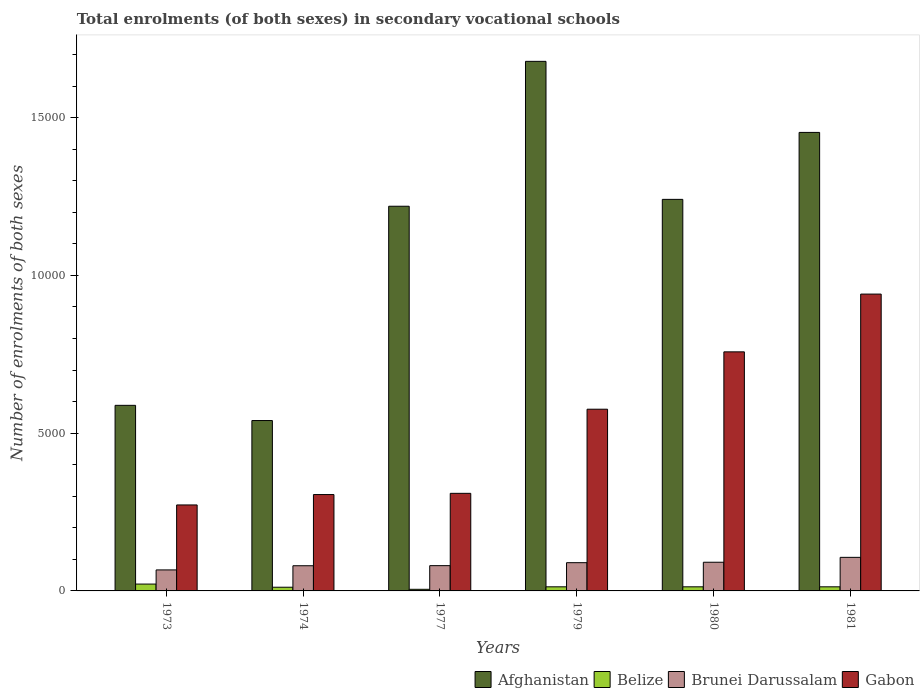How many different coloured bars are there?
Ensure brevity in your answer.  4. Are the number of bars on each tick of the X-axis equal?
Give a very brief answer. Yes. How many bars are there on the 3rd tick from the left?
Provide a short and direct response. 4. What is the number of enrolments in secondary schools in Brunei Darussalam in 1977?
Ensure brevity in your answer.  801. Across all years, what is the maximum number of enrolments in secondary schools in Brunei Darussalam?
Keep it short and to the point. 1064. Across all years, what is the minimum number of enrolments in secondary schools in Gabon?
Provide a succinct answer. 2725. In which year was the number of enrolments in secondary schools in Brunei Darussalam maximum?
Your answer should be very brief. 1981. In which year was the number of enrolments in secondary schools in Afghanistan minimum?
Keep it short and to the point. 1974. What is the total number of enrolments in secondary schools in Brunei Darussalam in the graph?
Keep it short and to the point. 5133. What is the difference between the number of enrolments in secondary schools in Afghanistan in 1979 and that in 1981?
Your answer should be very brief. 2252. What is the difference between the number of enrolments in secondary schools in Belize in 1981 and the number of enrolments in secondary schools in Brunei Darussalam in 1977?
Give a very brief answer. -671. What is the average number of enrolments in secondary schools in Belize per year?
Ensure brevity in your answer.  129.17. In the year 1974, what is the difference between the number of enrolments in secondary schools in Gabon and number of enrolments in secondary schools in Afghanistan?
Keep it short and to the point. -2346. In how many years, is the number of enrolments in secondary schools in Brunei Darussalam greater than 3000?
Make the answer very short. 0. What is the ratio of the number of enrolments in secondary schools in Belize in 1979 to that in 1980?
Offer a terse response. 1. Is the number of enrolments in secondary schools in Belize in 1980 less than that in 1981?
Offer a very short reply. No. Is the difference between the number of enrolments in secondary schools in Gabon in 1974 and 1980 greater than the difference between the number of enrolments in secondary schools in Afghanistan in 1974 and 1980?
Offer a very short reply. Yes. What is the difference between the highest and the second highest number of enrolments in secondary schools in Afghanistan?
Ensure brevity in your answer.  2252. What is the difference between the highest and the lowest number of enrolments in secondary schools in Afghanistan?
Your answer should be compact. 1.14e+04. Is the sum of the number of enrolments in secondary schools in Gabon in 1973 and 1981 greater than the maximum number of enrolments in secondary schools in Belize across all years?
Make the answer very short. Yes. What does the 1st bar from the left in 1974 represents?
Make the answer very short. Afghanistan. What does the 2nd bar from the right in 1974 represents?
Your answer should be compact. Brunei Darussalam. Is it the case that in every year, the sum of the number of enrolments in secondary schools in Afghanistan and number of enrolments in secondary schools in Brunei Darussalam is greater than the number of enrolments in secondary schools in Belize?
Your response must be concise. Yes. How many bars are there?
Provide a short and direct response. 24. Are all the bars in the graph horizontal?
Your answer should be very brief. No. Does the graph contain grids?
Provide a succinct answer. No. Where does the legend appear in the graph?
Provide a succinct answer. Bottom right. How many legend labels are there?
Keep it short and to the point. 4. What is the title of the graph?
Offer a terse response. Total enrolments (of both sexes) in secondary vocational schools. What is the label or title of the Y-axis?
Give a very brief answer. Number of enrolments of both sexes. What is the Number of enrolments of both sexes of Afghanistan in 1973?
Provide a short and direct response. 5882. What is the Number of enrolments of both sexes in Belize in 1973?
Provide a succinct answer. 217. What is the Number of enrolments of both sexes of Brunei Darussalam in 1973?
Offer a very short reply. 666. What is the Number of enrolments of both sexes in Gabon in 1973?
Your answer should be compact. 2725. What is the Number of enrolments of both sexes of Afghanistan in 1974?
Provide a short and direct response. 5400. What is the Number of enrolments of both sexes in Belize in 1974?
Give a very brief answer. 117. What is the Number of enrolments of both sexes in Brunei Darussalam in 1974?
Keep it short and to the point. 798. What is the Number of enrolments of both sexes of Gabon in 1974?
Provide a succinct answer. 3054. What is the Number of enrolments of both sexes of Afghanistan in 1977?
Offer a terse response. 1.22e+04. What is the Number of enrolments of both sexes in Belize in 1977?
Offer a terse response. 51. What is the Number of enrolments of both sexes in Brunei Darussalam in 1977?
Offer a terse response. 801. What is the Number of enrolments of both sexes in Gabon in 1977?
Make the answer very short. 3093. What is the Number of enrolments of both sexes in Afghanistan in 1979?
Your response must be concise. 1.68e+04. What is the Number of enrolments of both sexes in Belize in 1979?
Your answer should be compact. 130. What is the Number of enrolments of both sexes of Brunei Darussalam in 1979?
Keep it short and to the point. 895. What is the Number of enrolments of both sexes in Gabon in 1979?
Provide a succinct answer. 5759. What is the Number of enrolments of both sexes of Afghanistan in 1980?
Your response must be concise. 1.24e+04. What is the Number of enrolments of both sexes of Belize in 1980?
Offer a terse response. 130. What is the Number of enrolments of both sexes of Brunei Darussalam in 1980?
Provide a succinct answer. 909. What is the Number of enrolments of both sexes of Gabon in 1980?
Your answer should be very brief. 7577. What is the Number of enrolments of both sexes of Afghanistan in 1981?
Ensure brevity in your answer.  1.45e+04. What is the Number of enrolments of both sexes of Belize in 1981?
Provide a succinct answer. 130. What is the Number of enrolments of both sexes in Brunei Darussalam in 1981?
Make the answer very short. 1064. What is the Number of enrolments of both sexes of Gabon in 1981?
Provide a succinct answer. 9408. Across all years, what is the maximum Number of enrolments of both sexes in Afghanistan?
Offer a terse response. 1.68e+04. Across all years, what is the maximum Number of enrolments of both sexes in Belize?
Provide a succinct answer. 217. Across all years, what is the maximum Number of enrolments of both sexes of Brunei Darussalam?
Offer a very short reply. 1064. Across all years, what is the maximum Number of enrolments of both sexes in Gabon?
Keep it short and to the point. 9408. Across all years, what is the minimum Number of enrolments of both sexes of Afghanistan?
Offer a very short reply. 5400. Across all years, what is the minimum Number of enrolments of both sexes in Belize?
Your answer should be compact. 51. Across all years, what is the minimum Number of enrolments of both sexes of Brunei Darussalam?
Provide a short and direct response. 666. Across all years, what is the minimum Number of enrolments of both sexes of Gabon?
Offer a very short reply. 2725. What is the total Number of enrolments of both sexes of Afghanistan in the graph?
Your answer should be compact. 6.72e+04. What is the total Number of enrolments of both sexes in Belize in the graph?
Your answer should be very brief. 775. What is the total Number of enrolments of both sexes of Brunei Darussalam in the graph?
Offer a very short reply. 5133. What is the total Number of enrolments of both sexes in Gabon in the graph?
Give a very brief answer. 3.16e+04. What is the difference between the Number of enrolments of both sexes of Afghanistan in 1973 and that in 1974?
Your response must be concise. 482. What is the difference between the Number of enrolments of both sexes of Brunei Darussalam in 1973 and that in 1974?
Provide a short and direct response. -132. What is the difference between the Number of enrolments of both sexes of Gabon in 1973 and that in 1974?
Ensure brevity in your answer.  -329. What is the difference between the Number of enrolments of both sexes in Afghanistan in 1973 and that in 1977?
Your response must be concise. -6310. What is the difference between the Number of enrolments of both sexes in Belize in 1973 and that in 1977?
Give a very brief answer. 166. What is the difference between the Number of enrolments of both sexes in Brunei Darussalam in 1973 and that in 1977?
Provide a short and direct response. -135. What is the difference between the Number of enrolments of both sexes in Gabon in 1973 and that in 1977?
Offer a terse response. -368. What is the difference between the Number of enrolments of both sexes in Afghanistan in 1973 and that in 1979?
Offer a terse response. -1.09e+04. What is the difference between the Number of enrolments of both sexes of Belize in 1973 and that in 1979?
Give a very brief answer. 87. What is the difference between the Number of enrolments of both sexes in Brunei Darussalam in 1973 and that in 1979?
Your answer should be very brief. -229. What is the difference between the Number of enrolments of both sexes in Gabon in 1973 and that in 1979?
Make the answer very short. -3034. What is the difference between the Number of enrolments of both sexes in Afghanistan in 1973 and that in 1980?
Your response must be concise. -6528. What is the difference between the Number of enrolments of both sexes of Belize in 1973 and that in 1980?
Offer a very short reply. 87. What is the difference between the Number of enrolments of both sexes of Brunei Darussalam in 1973 and that in 1980?
Provide a short and direct response. -243. What is the difference between the Number of enrolments of both sexes in Gabon in 1973 and that in 1980?
Your response must be concise. -4852. What is the difference between the Number of enrolments of both sexes in Afghanistan in 1973 and that in 1981?
Offer a terse response. -8650. What is the difference between the Number of enrolments of both sexes in Brunei Darussalam in 1973 and that in 1981?
Ensure brevity in your answer.  -398. What is the difference between the Number of enrolments of both sexes of Gabon in 1973 and that in 1981?
Offer a very short reply. -6683. What is the difference between the Number of enrolments of both sexes in Afghanistan in 1974 and that in 1977?
Provide a succinct answer. -6792. What is the difference between the Number of enrolments of both sexes in Gabon in 1974 and that in 1977?
Your response must be concise. -39. What is the difference between the Number of enrolments of both sexes of Afghanistan in 1974 and that in 1979?
Offer a very short reply. -1.14e+04. What is the difference between the Number of enrolments of both sexes of Brunei Darussalam in 1974 and that in 1979?
Provide a succinct answer. -97. What is the difference between the Number of enrolments of both sexes of Gabon in 1974 and that in 1979?
Your answer should be very brief. -2705. What is the difference between the Number of enrolments of both sexes of Afghanistan in 1974 and that in 1980?
Offer a terse response. -7010. What is the difference between the Number of enrolments of both sexes in Brunei Darussalam in 1974 and that in 1980?
Provide a short and direct response. -111. What is the difference between the Number of enrolments of both sexes in Gabon in 1974 and that in 1980?
Offer a very short reply. -4523. What is the difference between the Number of enrolments of both sexes in Afghanistan in 1974 and that in 1981?
Keep it short and to the point. -9132. What is the difference between the Number of enrolments of both sexes in Belize in 1974 and that in 1981?
Your response must be concise. -13. What is the difference between the Number of enrolments of both sexes in Brunei Darussalam in 1974 and that in 1981?
Offer a terse response. -266. What is the difference between the Number of enrolments of both sexes of Gabon in 1974 and that in 1981?
Your answer should be compact. -6354. What is the difference between the Number of enrolments of both sexes of Afghanistan in 1977 and that in 1979?
Offer a terse response. -4592. What is the difference between the Number of enrolments of both sexes in Belize in 1977 and that in 1979?
Your response must be concise. -79. What is the difference between the Number of enrolments of both sexes in Brunei Darussalam in 1977 and that in 1979?
Ensure brevity in your answer.  -94. What is the difference between the Number of enrolments of both sexes in Gabon in 1977 and that in 1979?
Your answer should be very brief. -2666. What is the difference between the Number of enrolments of both sexes in Afghanistan in 1977 and that in 1980?
Provide a succinct answer. -218. What is the difference between the Number of enrolments of both sexes in Belize in 1977 and that in 1980?
Your answer should be compact. -79. What is the difference between the Number of enrolments of both sexes of Brunei Darussalam in 1977 and that in 1980?
Your response must be concise. -108. What is the difference between the Number of enrolments of both sexes in Gabon in 1977 and that in 1980?
Offer a very short reply. -4484. What is the difference between the Number of enrolments of both sexes of Afghanistan in 1977 and that in 1981?
Provide a short and direct response. -2340. What is the difference between the Number of enrolments of both sexes of Belize in 1977 and that in 1981?
Keep it short and to the point. -79. What is the difference between the Number of enrolments of both sexes in Brunei Darussalam in 1977 and that in 1981?
Your answer should be compact. -263. What is the difference between the Number of enrolments of both sexes of Gabon in 1977 and that in 1981?
Offer a very short reply. -6315. What is the difference between the Number of enrolments of both sexes in Afghanistan in 1979 and that in 1980?
Give a very brief answer. 4374. What is the difference between the Number of enrolments of both sexes in Belize in 1979 and that in 1980?
Your response must be concise. 0. What is the difference between the Number of enrolments of both sexes of Brunei Darussalam in 1979 and that in 1980?
Your answer should be compact. -14. What is the difference between the Number of enrolments of both sexes of Gabon in 1979 and that in 1980?
Give a very brief answer. -1818. What is the difference between the Number of enrolments of both sexes in Afghanistan in 1979 and that in 1981?
Your answer should be very brief. 2252. What is the difference between the Number of enrolments of both sexes in Belize in 1979 and that in 1981?
Provide a succinct answer. 0. What is the difference between the Number of enrolments of both sexes in Brunei Darussalam in 1979 and that in 1981?
Keep it short and to the point. -169. What is the difference between the Number of enrolments of both sexes in Gabon in 1979 and that in 1981?
Keep it short and to the point. -3649. What is the difference between the Number of enrolments of both sexes of Afghanistan in 1980 and that in 1981?
Ensure brevity in your answer.  -2122. What is the difference between the Number of enrolments of both sexes in Brunei Darussalam in 1980 and that in 1981?
Keep it short and to the point. -155. What is the difference between the Number of enrolments of both sexes of Gabon in 1980 and that in 1981?
Provide a succinct answer. -1831. What is the difference between the Number of enrolments of both sexes of Afghanistan in 1973 and the Number of enrolments of both sexes of Belize in 1974?
Offer a very short reply. 5765. What is the difference between the Number of enrolments of both sexes in Afghanistan in 1973 and the Number of enrolments of both sexes in Brunei Darussalam in 1974?
Give a very brief answer. 5084. What is the difference between the Number of enrolments of both sexes in Afghanistan in 1973 and the Number of enrolments of both sexes in Gabon in 1974?
Offer a terse response. 2828. What is the difference between the Number of enrolments of both sexes in Belize in 1973 and the Number of enrolments of both sexes in Brunei Darussalam in 1974?
Your answer should be very brief. -581. What is the difference between the Number of enrolments of both sexes of Belize in 1973 and the Number of enrolments of both sexes of Gabon in 1974?
Keep it short and to the point. -2837. What is the difference between the Number of enrolments of both sexes of Brunei Darussalam in 1973 and the Number of enrolments of both sexes of Gabon in 1974?
Provide a short and direct response. -2388. What is the difference between the Number of enrolments of both sexes in Afghanistan in 1973 and the Number of enrolments of both sexes in Belize in 1977?
Provide a short and direct response. 5831. What is the difference between the Number of enrolments of both sexes of Afghanistan in 1973 and the Number of enrolments of both sexes of Brunei Darussalam in 1977?
Your answer should be compact. 5081. What is the difference between the Number of enrolments of both sexes of Afghanistan in 1973 and the Number of enrolments of both sexes of Gabon in 1977?
Provide a short and direct response. 2789. What is the difference between the Number of enrolments of both sexes of Belize in 1973 and the Number of enrolments of both sexes of Brunei Darussalam in 1977?
Keep it short and to the point. -584. What is the difference between the Number of enrolments of both sexes in Belize in 1973 and the Number of enrolments of both sexes in Gabon in 1977?
Your answer should be compact. -2876. What is the difference between the Number of enrolments of both sexes of Brunei Darussalam in 1973 and the Number of enrolments of both sexes of Gabon in 1977?
Keep it short and to the point. -2427. What is the difference between the Number of enrolments of both sexes of Afghanistan in 1973 and the Number of enrolments of both sexes of Belize in 1979?
Your answer should be compact. 5752. What is the difference between the Number of enrolments of both sexes of Afghanistan in 1973 and the Number of enrolments of both sexes of Brunei Darussalam in 1979?
Your answer should be compact. 4987. What is the difference between the Number of enrolments of both sexes in Afghanistan in 1973 and the Number of enrolments of both sexes in Gabon in 1979?
Ensure brevity in your answer.  123. What is the difference between the Number of enrolments of both sexes in Belize in 1973 and the Number of enrolments of both sexes in Brunei Darussalam in 1979?
Your response must be concise. -678. What is the difference between the Number of enrolments of both sexes of Belize in 1973 and the Number of enrolments of both sexes of Gabon in 1979?
Your response must be concise. -5542. What is the difference between the Number of enrolments of both sexes in Brunei Darussalam in 1973 and the Number of enrolments of both sexes in Gabon in 1979?
Your response must be concise. -5093. What is the difference between the Number of enrolments of both sexes of Afghanistan in 1973 and the Number of enrolments of both sexes of Belize in 1980?
Your response must be concise. 5752. What is the difference between the Number of enrolments of both sexes of Afghanistan in 1973 and the Number of enrolments of both sexes of Brunei Darussalam in 1980?
Offer a terse response. 4973. What is the difference between the Number of enrolments of both sexes in Afghanistan in 1973 and the Number of enrolments of both sexes in Gabon in 1980?
Provide a succinct answer. -1695. What is the difference between the Number of enrolments of both sexes of Belize in 1973 and the Number of enrolments of both sexes of Brunei Darussalam in 1980?
Your response must be concise. -692. What is the difference between the Number of enrolments of both sexes of Belize in 1973 and the Number of enrolments of both sexes of Gabon in 1980?
Your response must be concise. -7360. What is the difference between the Number of enrolments of both sexes of Brunei Darussalam in 1973 and the Number of enrolments of both sexes of Gabon in 1980?
Offer a very short reply. -6911. What is the difference between the Number of enrolments of both sexes of Afghanistan in 1973 and the Number of enrolments of both sexes of Belize in 1981?
Your answer should be very brief. 5752. What is the difference between the Number of enrolments of both sexes of Afghanistan in 1973 and the Number of enrolments of both sexes of Brunei Darussalam in 1981?
Your answer should be compact. 4818. What is the difference between the Number of enrolments of both sexes of Afghanistan in 1973 and the Number of enrolments of both sexes of Gabon in 1981?
Provide a succinct answer. -3526. What is the difference between the Number of enrolments of both sexes in Belize in 1973 and the Number of enrolments of both sexes in Brunei Darussalam in 1981?
Provide a short and direct response. -847. What is the difference between the Number of enrolments of both sexes in Belize in 1973 and the Number of enrolments of both sexes in Gabon in 1981?
Make the answer very short. -9191. What is the difference between the Number of enrolments of both sexes of Brunei Darussalam in 1973 and the Number of enrolments of both sexes of Gabon in 1981?
Provide a succinct answer. -8742. What is the difference between the Number of enrolments of both sexes of Afghanistan in 1974 and the Number of enrolments of both sexes of Belize in 1977?
Ensure brevity in your answer.  5349. What is the difference between the Number of enrolments of both sexes in Afghanistan in 1974 and the Number of enrolments of both sexes in Brunei Darussalam in 1977?
Provide a succinct answer. 4599. What is the difference between the Number of enrolments of both sexes of Afghanistan in 1974 and the Number of enrolments of both sexes of Gabon in 1977?
Your answer should be very brief. 2307. What is the difference between the Number of enrolments of both sexes in Belize in 1974 and the Number of enrolments of both sexes in Brunei Darussalam in 1977?
Your response must be concise. -684. What is the difference between the Number of enrolments of both sexes of Belize in 1974 and the Number of enrolments of both sexes of Gabon in 1977?
Keep it short and to the point. -2976. What is the difference between the Number of enrolments of both sexes of Brunei Darussalam in 1974 and the Number of enrolments of both sexes of Gabon in 1977?
Ensure brevity in your answer.  -2295. What is the difference between the Number of enrolments of both sexes of Afghanistan in 1974 and the Number of enrolments of both sexes of Belize in 1979?
Your response must be concise. 5270. What is the difference between the Number of enrolments of both sexes in Afghanistan in 1974 and the Number of enrolments of both sexes in Brunei Darussalam in 1979?
Your answer should be compact. 4505. What is the difference between the Number of enrolments of both sexes of Afghanistan in 1974 and the Number of enrolments of both sexes of Gabon in 1979?
Offer a terse response. -359. What is the difference between the Number of enrolments of both sexes of Belize in 1974 and the Number of enrolments of both sexes of Brunei Darussalam in 1979?
Offer a terse response. -778. What is the difference between the Number of enrolments of both sexes in Belize in 1974 and the Number of enrolments of both sexes in Gabon in 1979?
Give a very brief answer. -5642. What is the difference between the Number of enrolments of both sexes in Brunei Darussalam in 1974 and the Number of enrolments of both sexes in Gabon in 1979?
Your answer should be compact. -4961. What is the difference between the Number of enrolments of both sexes of Afghanistan in 1974 and the Number of enrolments of both sexes of Belize in 1980?
Give a very brief answer. 5270. What is the difference between the Number of enrolments of both sexes in Afghanistan in 1974 and the Number of enrolments of both sexes in Brunei Darussalam in 1980?
Provide a short and direct response. 4491. What is the difference between the Number of enrolments of both sexes of Afghanistan in 1974 and the Number of enrolments of both sexes of Gabon in 1980?
Your answer should be compact. -2177. What is the difference between the Number of enrolments of both sexes in Belize in 1974 and the Number of enrolments of both sexes in Brunei Darussalam in 1980?
Provide a short and direct response. -792. What is the difference between the Number of enrolments of both sexes of Belize in 1974 and the Number of enrolments of both sexes of Gabon in 1980?
Ensure brevity in your answer.  -7460. What is the difference between the Number of enrolments of both sexes of Brunei Darussalam in 1974 and the Number of enrolments of both sexes of Gabon in 1980?
Keep it short and to the point. -6779. What is the difference between the Number of enrolments of both sexes of Afghanistan in 1974 and the Number of enrolments of both sexes of Belize in 1981?
Provide a succinct answer. 5270. What is the difference between the Number of enrolments of both sexes in Afghanistan in 1974 and the Number of enrolments of both sexes in Brunei Darussalam in 1981?
Give a very brief answer. 4336. What is the difference between the Number of enrolments of both sexes in Afghanistan in 1974 and the Number of enrolments of both sexes in Gabon in 1981?
Make the answer very short. -4008. What is the difference between the Number of enrolments of both sexes in Belize in 1974 and the Number of enrolments of both sexes in Brunei Darussalam in 1981?
Make the answer very short. -947. What is the difference between the Number of enrolments of both sexes of Belize in 1974 and the Number of enrolments of both sexes of Gabon in 1981?
Your answer should be very brief. -9291. What is the difference between the Number of enrolments of both sexes of Brunei Darussalam in 1974 and the Number of enrolments of both sexes of Gabon in 1981?
Provide a succinct answer. -8610. What is the difference between the Number of enrolments of both sexes of Afghanistan in 1977 and the Number of enrolments of both sexes of Belize in 1979?
Give a very brief answer. 1.21e+04. What is the difference between the Number of enrolments of both sexes in Afghanistan in 1977 and the Number of enrolments of both sexes in Brunei Darussalam in 1979?
Offer a terse response. 1.13e+04. What is the difference between the Number of enrolments of both sexes of Afghanistan in 1977 and the Number of enrolments of both sexes of Gabon in 1979?
Your answer should be compact. 6433. What is the difference between the Number of enrolments of both sexes of Belize in 1977 and the Number of enrolments of both sexes of Brunei Darussalam in 1979?
Offer a terse response. -844. What is the difference between the Number of enrolments of both sexes of Belize in 1977 and the Number of enrolments of both sexes of Gabon in 1979?
Offer a terse response. -5708. What is the difference between the Number of enrolments of both sexes of Brunei Darussalam in 1977 and the Number of enrolments of both sexes of Gabon in 1979?
Offer a very short reply. -4958. What is the difference between the Number of enrolments of both sexes in Afghanistan in 1977 and the Number of enrolments of both sexes in Belize in 1980?
Ensure brevity in your answer.  1.21e+04. What is the difference between the Number of enrolments of both sexes of Afghanistan in 1977 and the Number of enrolments of both sexes of Brunei Darussalam in 1980?
Provide a succinct answer. 1.13e+04. What is the difference between the Number of enrolments of both sexes of Afghanistan in 1977 and the Number of enrolments of both sexes of Gabon in 1980?
Your answer should be compact. 4615. What is the difference between the Number of enrolments of both sexes of Belize in 1977 and the Number of enrolments of both sexes of Brunei Darussalam in 1980?
Your answer should be compact. -858. What is the difference between the Number of enrolments of both sexes of Belize in 1977 and the Number of enrolments of both sexes of Gabon in 1980?
Your response must be concise. -7526. What is the difference between the Number of enrolments of both sexes in Brunei Darussalam in 1977 and the Number of enrolments of both sexes in Gabon in 1980?
Offer a very short reply. -6776. What is the difference between the Number of enrolments of both sexes of Afghanistan in 1977 and the Number of enrolments of both sexes of Belize in 1981?
Keep it short and to the point. 1.21e+04. What is the difference between the Number of enrolments of both sexes in Afghanistan in 1977 and the Number of enrolments of both sexes in Brunei Darussalam in 1981?
Your answer should be very brief. 1.11e+04. What is the difference between the Number of enrolments of both sexes of Afghanistan in 1977 and the Number of enrolments of both sexes of Gabon in 1981?
Offer a terse response. 2784. What is the difference between the Number of enrolments of both sexes of Belize in 1977 and the Number of enrolments of both sexes of Brunei Darussalam in 1981?
Your response must be concise. -1013. What is the difference between the Number of enrolments of both sexes of Belize in 1977 and the Number of enrolments of both sexes of Gabon in 1981?
Give a very brief answer. -9357. What is the difference between the Number of enrolments of both sexes in Brunei Darussalam in 1977 and the Number of enrolments of both sexes in Gabon in 1981?
Offer a terse response. -8607. What is the difference between the Number of enrolments of both sexes in Afghanistan in 1979 and the Number of enrolments of both sexes in Belize in 1980?
Give a very brief answer. 1.67e+04. What is the difference between the Number of enrolments of both sexes in Afghanistan in 1979 and the Number of enrolments of both sexes in Brunei Darussalam in 1980?
Offer a terse response. 1.59e+04. What is the difference between the Number of enrolments of both sexes in Afghanistan in 1979 and the Number of enrolments of both sexes in Gabon in 1980?
Offer a very short reply. 9207. What is the difference between the Number of enrolments of both sexes of Belize in 1979 and the Number of enrolments of both sexes of Brunei Darussalam in 1980?
Provide a short and direct response. -779. What is the difference between the Number of enrolments of both sexes of Belize in 1979 and the Number of enrolments of both sexes of Gabon in 1980?
Ensure brevity in your answer.  -7447. What is the difference between the Number of enrolments of both sexes of Brunei Darussalam in 1979 and the Number of enrolments of both sexes of Gabon in 1980?
Give a very brief answer. -6682. What is the difference between the Number of enrolments of both sexes of Afghanistan in 1979 and the Number of enrolments of both sexes of Belize in 1981?
Your response must be concise. 1.67e+04. What is the difference between the Number of enrolments of both sexes of Afghanistan in 1979 and the Number of enrolments of both sexes of Brunei Darussalam in 1981?
Ensure brevity in your answer.  1.57e+04. What is the difference between the Number of enrolments of both sexes of Afghanistan in 1979 and the Number of enrolments of both sexes of Gabon in 1981?
Offer a very short reply. 7376. What is the difference between the Number of enrolments of both sexes in Belize in 1979 and the Number of enrolments of both sexes in Brunei Darussalam in 1981?
Your response must be concise. -934. What is the difference between the Number of enrolments of both sexes in Belize in 1979 and the Number of enrolments of both sexes in Gabon in 1981?
Provide a succinct answer. -9278. What is the difference between the Number of enrolments of both sexes in Brunei Darussalam in 1979 and the Number of enrolments of both sexes in Gabon in 1981?
Provide a succinct answer. -8513. What is the difference between the Number of enrolments of both sexes in Afghanistan in 1980 and the Number of enrolments of both sexes in Belize in 1981?
Give a very brief answer. 1.23e+04. What is the difference between the Number of enrolments of both sexes of Afghanistan in 1980 and the Number of enrolments of both sexes of Brunei Darussalam in 1981?
Provide a short and direct response. 1.13e+04. What is the difference between the Number of enrolments of both sexes in Afghanistan in 1980 and the Number of enrolments of both sexes in Gabon in 1981?
Offer a terse response. 3002. What is the difference between the Number of enrolments of both sexes of Belize in 1980 and the Number of enrolments of both sexes of Brunei Darussalam in 1981?
Make the answer very short. -934. What is the difference between the Number of enrolments of both sexes of Belize in 1980 and the Number of enrolments of both sexes of Gabon in 1981?
Your response must be concise. -9278. What is the difference between the Number of enrolments of both sexes of Brunei Darussalam in 1980 and the Number of enrolments of both sexes of Gabon in 1981?
Keep it short and to the point. -8499. What is the average Number of enrolments of both sexes of Afghanistan per year?
Keep it short and to the point. 1.12e+04. What is the average Number of enrolments of both sexes of Belize per year?
Keep it short and to the point. 129.17. What is the average Number of enrolments of both sexes in Brunei Darussalam per year?
Provide a short and direct response. 855.5. What is the average Number of enrolments of both sexes in Gabon per year?
Give a very brief answer. 5269.33. In the year 1973, what is the difference between the Number of enrolments of both sexes of Afghanistan and Number of enrolments of both sexes of Belize?
Keep it short and to the point. 5665. In the year 1973, what is the difference between the Number of enrolments of both sexes in Afghanistan and Number of enrolments of both sexes in Brunei Darussalam?
Offer a very short reply. 5216. In the year 1973, what is the difference between the Number of enrolments of both sexes in Afghanistan and Number of enrolments of both sexes in Gabon?
Your answer should be compact. 3157. In the year 1973, what is the difference between the Number of enrolments of both sexes in Belize and Number of enrolments of both sexes in Brunei Darussalam?
Offer a terse response. -449. In the year 1973, what is the difference between the Number of enrolments of both sexes in Belize and Number of enrolments of both sexes in Gabon?
Your answer should be very brief. -2508. In the year 1973, what is the difference between the Number of enrolments of both sexes of Brunei Darussalam and Number of enrolments of both sexes of Gabon?
Give a very brief answer. -2059. In the year 1974, what is the difference between the Number of enrolments of both sexes in Afghanistan and Number of enrolments of both sexes in Belize?
Give a very brief answer. 5283. In the year 1974, what is the difference between the Number of enrolments of both sexes of Afghanistan and Number of enrolments of both sexes of Brunei Darussalam?
Provide a short and direct response. 4602. In the year 1974, what is the difference between the Number of enrolments of both sexes of Afghanistan and Number of enrolments of both sexes of Gabon?
Provide a succinct answer. 2346. In the year 1974, what is the difference between the Number of enrolments of both sexes in Belize and Number of enrolments of both sexes in Brunei Darussalam?
Offer a terse response. -681. In the year 1974, what is the difference between the Number of enrolments of both sexes of Belize and Number of enrolments of both sexes of Gabon?
Offer a terse response. -2937. In the year 1974, what is the difference between the Number of enrolments of both sexes of Brunei Darussalam and Number of enrolments of both sexes of Gabon?
Give a very brief answer. -2256. In the year 1977, what is the difference between the Number of enrolments of both sexes of Afghanistan and Number of enrolments of both sexes of Belize?
Give a very brief answer. 1.21e+04. In the year 1977, what is the difference between the Number of enrolments of both sexes in Afghanistan and Number of enrolments of both sexes in Brunei Darussalam?
Your answer should be very brief. 1.14e+04. In the year 1977, what is the difference between the Number of enrolments of both sexes in Afghanistan and Number of enrolments of both sexes in Gabon?
Your answer should be compact. 9099. In the year 1977, what is the difference between the Number of enrolments of both sexes in Belize and Number of enrolments of both sexes in Brunei Darussalam?
Provide a succinct answer. -750. In the year 1977, what is the difference between the Number of enrolments of both sexes in Belize and Number of enrolments of both sexes in Gabon?
Keep it short and to the point. -3042. In the year 1977, what is the difference between the Number of enrolments of both sexes in Brunei Darussalam and Number of enrolments of both sexes in Gabon?
Offer a very short reply. -2292. In the year 1979, what is the difference between the Number of enrolments of both sexes of Afghanistan and Number of enrolments of both sexes of Belize?
Keep it short and to the point. 1.67e+04. In the year 1979, what is the difference between the Number of enrolments of both sexes in Afghanistan and Number of enrolments of both sexes in Brunei Darussalam?
Offer a terse response. 1.59e+04. In the year 1979, what is the difference between the Number of enrolments of both sexes of Afghanistan and Number of enrolments of both sexes of Gabon?
Give a very brief answer. 1.10e+04. In the year 1979, what is the difference between the Number of enrolments of both sexes in Belize and Number of enrolments of both sexes in Brunei Darussalam?
Offer a very short reply. -765. In the year 1979, what is the difference between the Number of enrolments of both sexes of Belize and Number of enrolments of both sexes of Gabon?
Provide a short and direct response. -5629. In the year 1979, what is the difference between the Number of enrolments of both sexes in Brunei Darussalam and Number of enrolments of both sexes in Gabon?
Your answer should be compact. -4864. In the year 1980, what is the difference between the Number of enrolments of both sexes in Afghanistan and Number of enrolments of both sexes in Belize?
Keep it short and to the point. 1.23e+04. In the year 1980, what is the difference between the Number of enrolments of both sexes in Afghanistan and Number of enrolments of both sexes in Brunei Darussalam?
Give a very brief answer. 1.15e+04. In the year 1980, what is the difference between the Number of enrolments of both sexes in Afghanistan and Number of enrolments of both sexes in Gabon?
Your answer should be compact. 4833. In the year 1980, what is the difference between the Number of enrolments of both sexes in Belize and Number of enrolments of both sexes in Brunei Darussalam?
Your answer should be compact. -779. In the year 1980, what is the difference between the Number of enrolments of both sexes in Belize and Number of enrolments of both sexes in Gabon?
Provide a short and direct response. -7447. In the year 1980, what is the difference between the Number of enrolments of both sexes in Brunei Darussalam and Number of enrolments of both sexes in Gabon?
Make the answer very short. -6668. In the year 1981, what is the difference between the Number of enrolments of both sexes of Afghanistan and Number of enrolments of both sexes of Belize?
Ensure brevity in your answer.  1.44e+04. In the year 1981, what is the difference between the Number of enrolments of both sexes of Afghanistan and Number of enrolments of both sexes of Brunei Darussalam?
Provide a short and direct response. 1.35e+04. In the year 1981, what is the difference between the Number of enrolments of both sexes in Afghanistan and Number of enrolments of both sexes in Gabon?
Keep it short and to the point. 5124. In the year 1981, what is the difference between the Number of enrolments of both sexes in Belize and Number of enrolments of both sexes in Brunei Darussalam?
Provide a short and direct response. -934. In the year 1981, what is the difference between the Number of enrolments of both sexes of Belize and Number of enrolments of both sexes of Gabon?
Ensure brevity in your answer.  -9278. In the year 1981, what is the difference between the Number of enrolments of both sexes of Brunei Darussalam and Number of enrolments of both sexes of Gabon?
Ensure brevity in your answer.  -8344. What is the ratio of the Number of enrolments of both sexes of Afghanistan in 1973 to that in 1974?
Keep it short and to the point. 1.09. What is the ratio of the Number of enrolments of both sexes of Belize in 1973 to that in 1974?
Provide a short and direct response. 1.85. What is the ratio of the Number of enrolments of both sexes in Brunei Darussalam in 1973 to that in 1974?
Provide a short and direct response. 0.83. What is the ratio of the Number of enrolments of both sexes in Gabon in 1973 to that in 1974?
Give a very brief answer. 0.89. What is the ratio of the Number of enrolments of both sexes in Afghanistan in 1973 to that in 1977?
Offer a very short reply. 0.48. What is the ratio of the Number of enrolments of both sexes in Belize in 1973 to that in 1977?
Keep it short and to the point. 4.25. What is the ratio of the Number of enrolments of both sexes of Brunei Darussalam in 1973 to that in 1977?
Make the answer very short. 0.83. What is the ratio of the Number of enrolments of both sexes of Gabon in 1973 to that in 1977?
Make the answer very short. 0.88. What is the ratio of the Number of enrolments of both sexes in Afghanistan in 1973 to that in 1979?
Your response must be concise. 0.35. What is the ratio of the Number of enrolments of both sexes of Belize in 1973 to that in 1979?
Give a very brief answer. 1.67. What is the ratio of the Number of enrolments of both sexes of Brunei Darussalam in 1973 to that in 1979?
Ensure brevity in your answer.  0.74. What is the ratio of the Number of enrolments of both sexes in Gabon in 1973 to that in 1979?
Ensure brevity in your answer.  0.47. What is the ratio of the Number of enrolments of both sexes in Afghanistan in 1973 to that in 1980?
Offer a very short reply. 0.47. What is the ratio of the Number of enrolments of both sexes of Belize in 1973 to that in 1980?
Offer a terse response. 1.67. What is the ratio of the Number of enrolments of both sexes of Brunei Darussalam in 1973 to that in 1980?
Provide a succinct answer. 0.73. What is the ratio of the Number of enrolments of both sexes of Gabon in 1973 to that in 1980?
Your answer should be compact. 0.36. What is the ratio of the Number of enrolments of both sexes in Afghanistan in 1973 to that in 1981?
Your answer should be very brief. 0.4. What is the ratio of the Number of enrolments of both sexes in Belize in 1973 to that in 1981?
Provide a short and direct response. 1.67. What is the ratio of the Number of enrolments of both sexes of Brunei Darussalam in 1973 to that in 1981?
Offer a terse response. 0.63. What is the ratio of the Number of enrolments of both sexes of Gabon in 1973 to that in 1981?
Ensure brevity in your answer.  0.29. What is the ratio of the Number of enrolments of both sexes in Afghanistan in 1974 to that in 1977?
Offer a terse response. 0.44. What is the ratio of the Number of enrolments of both sexes of Belize in 1974 to that in 1977?
Keep it short and to the point. 2.29. What is the ratio of the Number of enrolments of both sexes of Brunei Darussalam in 1974 to that in 1977?
Ensure brevity in your answer.  1. What is the ratio of the Number of enrolments of both sexes of Gabon in 1974 to that in 1977?
Offer a terse response. 0.99. What is the ratio of the Number of enrolments of both sexes of Afghanistan in 1974 to that in 1979?
Your answer should be very brief. 0.32. What is the ratio of the Number of enrolments of both sexes in Brunei Darussalam in 1974 to that in 1979?
Your answer should be compact. 0.89. What is the ratio of the Number of enrolments of both sexes in Gabon in 1974 to that in 1979?
Offer a terse response. 0.53. What is the ratio of the Number of enrolments of both sexes of Afghanistan in 1974 to that in 1980?
Your response must be concise. 0.44. What is the ratio of the Number of enrolments of both sexes of Brunei Darussalam in 1974 to that in 1980?
Your answer should be compact. 0.88. What is the ratio of the Number of enrolments of both sexes in Gabon in 1974 to that in 1980?
Ensure brevity in your answer.  0.4. What is the ratio of the Number of enrolments of both sexes in Afghanistan in 1974 to that in 1981?
Ensure brevity in your answer.  0.37. What is the ratio of the Number of enrolments of both sexes in Gabon in 1974 to that in 1981?
Offer a very short reply. 0.32. What is the ratio of the Number of enrolments of both sexes of Afghanistan in 1977 to that in 1979?
Make the answer very short. 0.73. What is the ratio of the Number of enrolments of both sexes in Belize in 1977 to that in 1979?
Keep it short and to the point. 0.39. What is the ratio of the Number of enrolments of both sexes of Brunei Darussalam in 1977 to that in 1979?
Keep it short and to the point. 0.9. What is the ratio of the Number of enrolments of both sexes of Gabon in 1977 to that in 1979?
Provide a succinct answer. 0.54. What is the ratio of the Number of enrolments of both sexes in Afghanistan in 1977 to that in 1980?
Make the answer very short. 0.98. What is the ratio of the Number of enrolments of both sexes in Belize in 1977 to that in 1980?
Offer a very short reply. 0.39. What is the ratio of the Number of enrolments of both sexes of Brunei Darussalam in 1977 to that in 1980?
Ensure brevity in your answer.  0.88. What is the ratio of the Number of enrolments of both sexes of Gabon in 1977 to that in 1980?
Ensure brevity in your answer.  0.41. What is the ratio of the Number of enrolments of both sexes in Afghanistan in 1977 to that in 1981?
Offer a very short reply. 0.84. What is the ratio of the Number of enrolments of both sexes in Belize in 1977 to that in 1981?
Your answer should be very brief. 0.39. What is the ratio of the Number of enrolments of both sexes in Brunei Darussalam in 1977 to that in 1981?
Provide a short and direct response. 0.75. What is the ratio of the Number of enrolments of both sexes of Gabon in 1977 to that in 1981?
Offer a very short reply. 0.33. What is the ratio of the Number of enrolments of both sexes of Afghanistan in 1979 to that in 1980?
Provide a short and direct response. 1.35. What is the ratio of the Number of enrolments of both sexes of Belize in 1979 to that in 1980?
Ensure brevity in your answer.  1. What is the ratio of the Number of enrolments of both sexes in Brunei Darussalam in 1979 to that in 1980?
Provide a short and direct response. 0.98. What is the ratio of the Number of enrolments of both sexes of Gabon in 1979 to that in 1980?
Offer a terse response. 0.76. What is the ratio of the Number of enrolments of both sexes of Afghanistan in 1979 to that in 1981?
Your answer should be compact. 1.16. What is the ratio of the Number of enrolments of both sexes of Belize in 1979 to that in 1981?
Offer a very short reply. 1. What is the ratio of the Number of enrolments of both sexes in Brunei Darussalam in 1979 to that in 1981?
Make the answer very short. 0.84. What is the ratio of the Number of enrolments of both sexes in Gabon in 1979 to that in 1981?
Ensure brevity in your answer.  0.61. What is the ratio of the Number of enrolments of both sexes of Afghanistan in 1980 to that in 1981?
Your answer should be compact. 0.85. What is the ratio of the Number of enrolments of both sexes in Belize in 1980 to that in 1981?
Give a very brief answer. 1. What is the ratio of the Number of enrolments of both sexes of Brunei Darussalam in 1980 to that in 1981?
Ensure brevity in your answer.  0.85. What is the ratio of the Number of enrolments of both sexes of Gabon in 1980 to that in 1981?
Provide a short and direct response. 0.81. What is the difference between the highest and the second highest Number of enrolments of both sexes of Afghanistan?
Your answer should be compact. 2252. What is the difference between the highest and the second highest Number of enrolments of both sexes of Brunei Darussalam?
Ensure brevity in your answer.  155. What is the difference between the highest and the second highest Number of enrolments of both sexes in Gabon?
Offer a very short reply. 1831. What is the difference between the highest and the lowest Number of enrolments of both sexes in Afghanistan?
Ensure brevity in your answer.  1.14e+04. What is the difference between the highest and the lowest Number of enrolments of both sexes of Belize?
Offer a very short reply. 166. What is the difference between the highest and the lowest Number of enrolments of both sexes of Brunei Darussalam?
Your answer should be compact. 398. What is the difference between the highest and the lowest Number of enrolments of both sexes in Gabon?
Your response must be concise. 6683. 